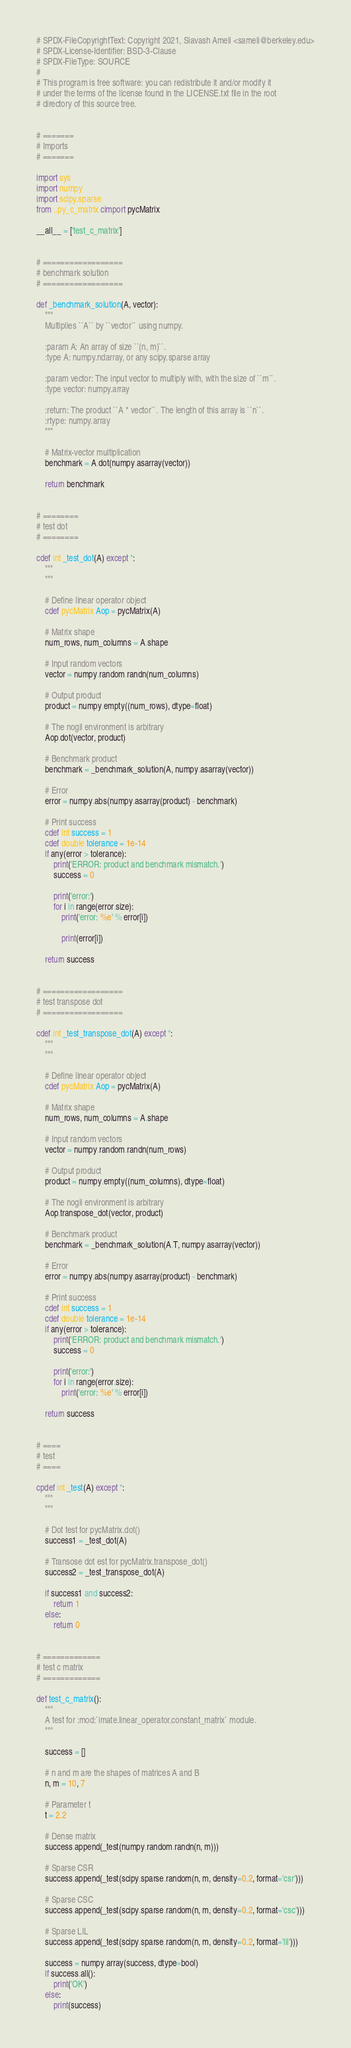<code> <loc_0><loc_0><loc_500><loc_500><_Cython_># SPDX-FileCopyrightText: Copyright 2021, Siavash Ameli <sameli@berkeley.edu>
# SPDX-License-Identifier: BSD-3-Clause
# SPDX-FileType: SOURCE
#
# This program is free software: you can redistribute it and/or modify it
# under the terms of the license found in the LICENSE.txt file in the root
# directory of this source tree.


# =======
# Imports
# =======

import sys
import numpy
import scipy.sparse
from ..py_c_matrix cimport pycMatrix

__all__ = ['test_c_matrix']


# ==================
# benchmark solution
# ==================

def _benchmark_solution(A, vector):
    """
    Multiplies ``A`` by ``vector`` using numpy.

    :param A: An array of size ``(n, m)``.
    :type A: numpy.ndarray, or any scipy.sparse array

    :param vector: The input vector to multiply with, with the size of ``m``.
    :type vector: numpy.array

    :return: The product ``A * vector``. The length of this array is ``n``.
    :rtype: numpy.array
    """

    # Matrix-vector multiplication
    benchmark = A.dot(numpy.asarray(vector))

    return benchmark


# ========
# test dot
# ========

cdef int _test_dot(A) except *:
    """
    """

    # Define linear operator object
    cdef pycMatrix Aop = pycMatrix(A)

    # Matrix shape
    num_rows, num_columns = A.shape

    # Input random vectors
    vector = numpy.random.randn(num_columns)

    # Output product
    product = numpy.empty((num_rows), dtype=float)

    # The nogil environment is arbitrary
    Aop.dot(vector, product)

    # Benchmark product
    benchmark = _benchmark_solution(A, numpy.asarray(vector))

    # Error
    error = numpy.abs(numpy.asarray(product) - benchmark)

    # Print success
    cdef int success = 1
    cdef double tolerance = 1e-14
    if any(error > tolerance):
        print('ERROR: product and benchmark mismatch.')
        success = 0

        print('error:')
        for i in range(error.size):
            print('error: %e' % error[i])

            print(error[i])

    return success


# ==================
# test transpose dot
# ==================

cdef int _test_transpose_dot(A) except *:
    """
    """

    # Define linear operator object
    cdef pycMatrix Aop = pycMatrix(A)

    # Matrix shape
    num_rows, num_columns = A.shape

    # Input random vectors
    vector = numpy.random.randn(num_rows)

    # Output product
    product = numpy.empty((num_columns), dtype=float)

    # The nogil environment is arbitrary
    Aop.transpose_dot(vector, product)

    # Benchmark product
    benchmark = _benchmark_solution(A.T, numpy.asarray(vector))

    # Error
    error = numpy.abs(numpy.asarray(product) - benchmark)

    # Print success
    cdef int success = 1
    cdef double tolerance = 1e-14
    if any(error > tolerance):
        print('ERROR: product and benchmark mismatch.')
        success = 0

        print('error:')
        for i in range(error.size):
            print('error: %e' % error[i])

    return success


# ====
# test
# ====

cpdef int _test(A) except *:
    """
    """

    # Dot test for pycMatrix.dot()
    success1 = _test_dot(A)

    # Transose dot est for pycMatrix.transpose_dot()
    success2 = _test_transpose_dot(A)

    if success1 and success2:
        return 1
    else:
        return 0


# =============
# test c matrix
# =============

def test_c_matrix():
    """
    A test for :mod:`imate.linear_operator.constant_matrix` module.
    """

    success = []

    # n and m are the shapes of matrices A and B
    n, m = 10, 7

    # Parameter t
    t = 2.2

    # Dense matrix
    success.append(_test(numpy.random.randn(n, m)))

    # Sparse CSR
    success.append(_test(scipy.sparse.random(n, m, density=0.2, format='csr')))

    # Sparse CSC
    success.append(_test(scipy.sparse.random(n, m, density=0.2, format='csc')))

    # Sparse LIL
    success.append(_test(scipy.sparse.random(n, m, density=0.2, format='lil')))

    success = numpy.array(success, dtype=bool)
    if success.all():
        print('OK')
    else:
        print(success)
</code> 